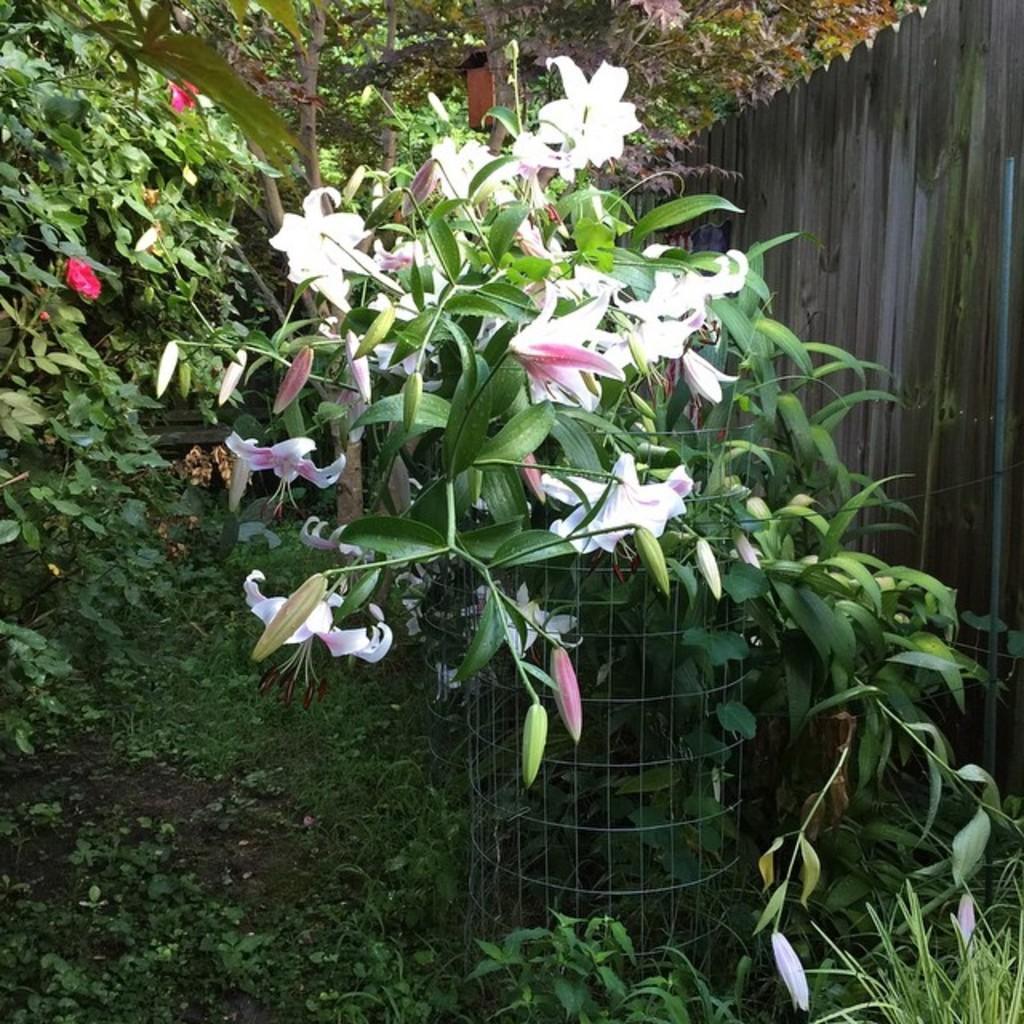Describe this image in one or two sentences. In this image there are plants, for one plant there is fencing,in the background there are trees, in the top right there is wooden wall. 